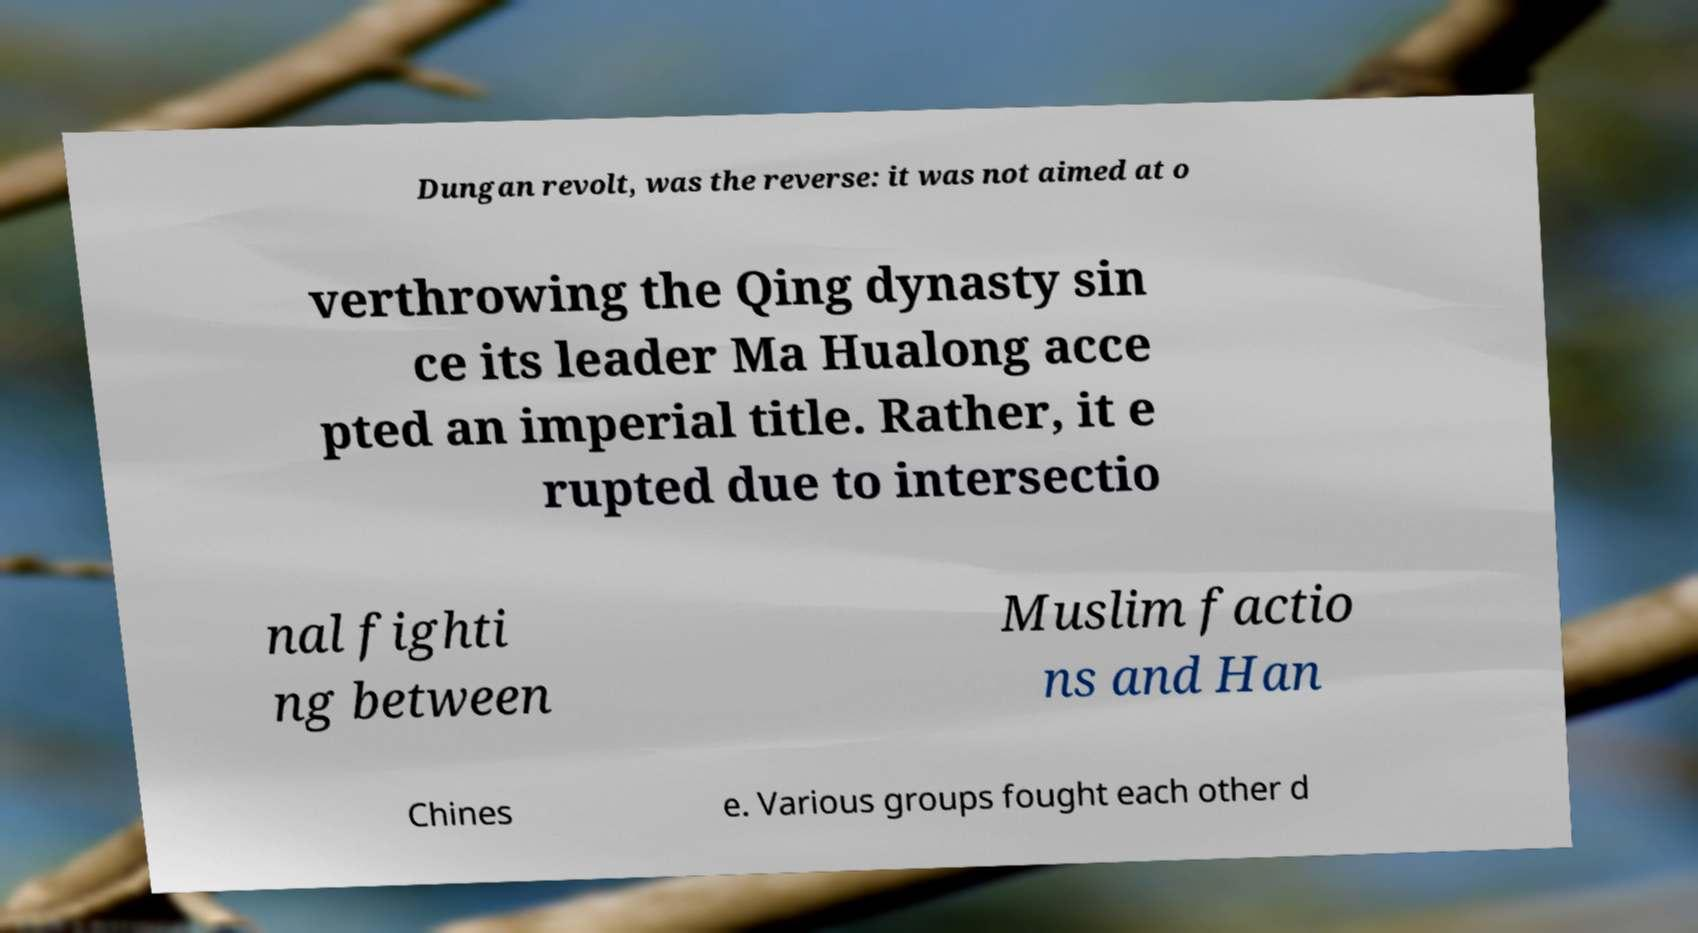For documentation purposes, I need the text within this image transcribed. Could you provide that? Dungan revolt, was the reverse: it was not aimed at o verthrowing the Qing dynasty sin ce its leader Ma Hualong acce pted an imperial title. Rather, it e rupted due to intersectio nal fighti ng between Muslim factio ns and Han Chines e. Various groups fought each other d 